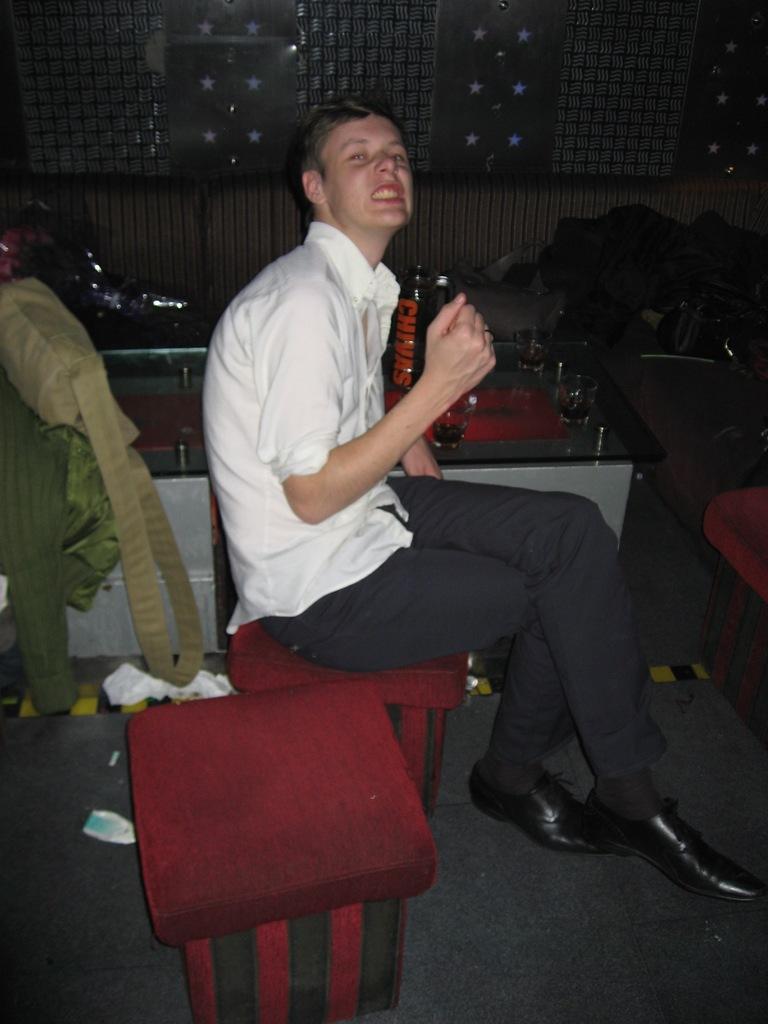Please provide a concise description of this image. In the foreground of this picture, there is a man sitting on a red stool and there is another red stool beside him. In the background, there are bags, a glass table on which glasses and few bottles are placed. There is also a wall and few chairs in the background. 